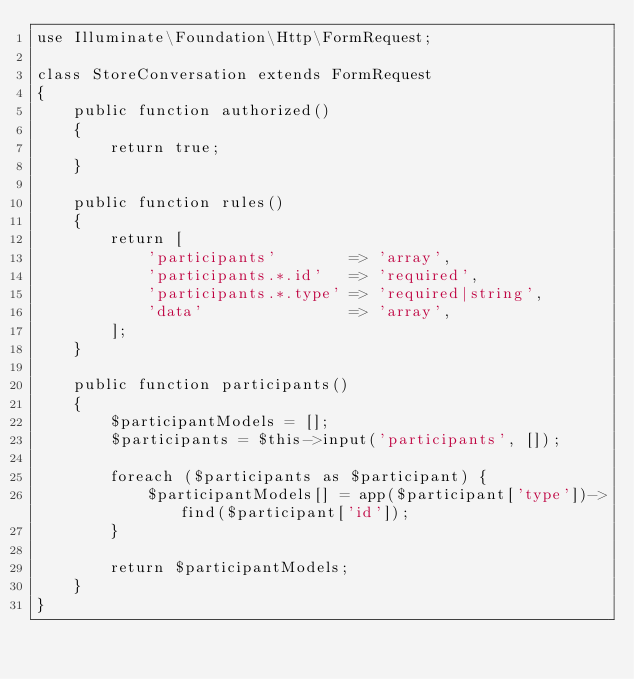Convert code to text. <code><loc_0><loc_0><loc_500><loc_500><_PHP_>use Illuminate\Foundation\Http\FormRequest;

class StoreConversation extends FormRequest
{
    public function authorized()
    {
        return true;
    }

    public function rules()
    {
        return [
            'participants'        => 'array',
            'participants.*.id'   => 'required',
            'participants.*.type' => 'required|string',
            'data'                => 'array',
        ];
    }

    public function participants()
    {
        $participantModels = [];
        $participants = $this->input('participants', []);

        foreach ($participants as $participant) {
            $participantModels[] = app($participant['type'])->find($participant['id']);
        }

        return $participantModels;
    }
}
</code> 